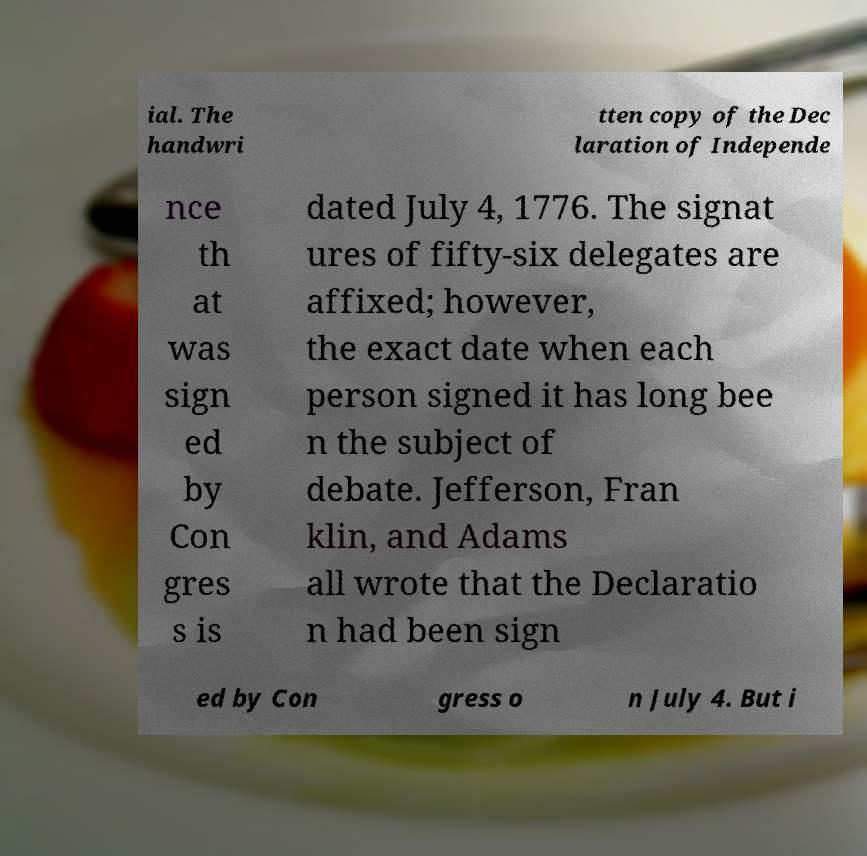Can you read and provide the text displayed in the image?This photo seems to have some interesting text. Can you extract and type it out for me? ial. The handwri tten copy of the Dec laration of Independe nce th at was sign ed by Con gres s is dated July 4, 1776. The signat ures of fifty-six delegates are affixed; however, the exact date when each person signed it has long bee n the subject of debate. Jefferson, Fran klin, and Adams all wrote that the Declaratio n had been sign ed by Con gress o n July 4. But i 